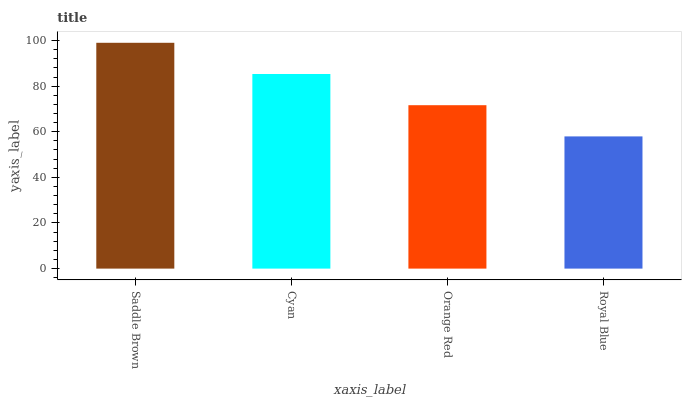Is Royal Blue the minimum?
Answer yes or no. Yes. Is Saddle Brown the maximum?
Answer yes or no. Yes. Is Cyan the minimum?
Answer yes or no. No. Is Cyan the maximum?
Answer yes or no. No. Is Saddle Brown greater than Cyan?
Answer yes or no. Yes. Is Cyan less than Saddle Brown?
Answer yes or no. Yes. Is Cyan greater than Saddle Brown?
Answer yes or no. No. Is Saddle Brown less than Cyan?
Answer yes or no. No. Is Cyan the high median?
Answer yes or no. Yes. Is Orange Red the low median?
Answer yes or no. Yes. Is Saddle Brown the high median?
Answer yes or no. No. Is Cyan the low median?
Answer yes or no. No. 